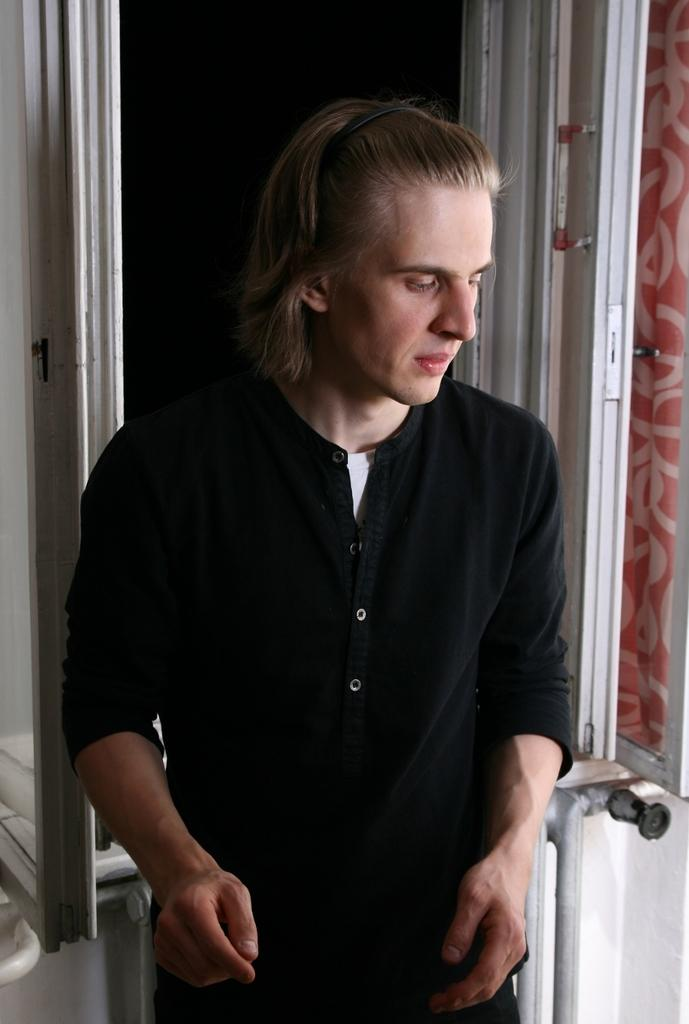Who or what is present in the image? There is a person in the image. What is the person standing or leaning against? There is a wall in the image. What material is visible in the image? There is cloth in the image. What else can be seen in the image besides the person and the wall? There are objects in the image. How would you describe the overall appearance of the image? The background of the image is dark. What type of theory is being discussed in the image? There is no indication in the image that a theory is being discussed. --- Facts: 1. There is a car in the image. 2. The car is red. 3. The car has four wheels. 4. There are people in the car. 5. The car is parked on the street. Absurd Topics: bird, ocean, mountain Conversation: What is the main subject of the image? The main subject of the image is a car. What color is the car? The car is red. How many wheels does the car have? The car has four wheels. Are there any passengers in the car? Yes, there are people in the car. Where is the car located in the image? The car is parked on the street. Reasoning: Let's think step by step in order to produce the conversation. We start by identifying the main subject in the image, which is the car. Then, we expand the conversation to include other details about the car, such as its color, number of wheels, and the presence of passengers. Finally, we describe the car's location in the image, which is parked on the street. Absurd Question/Answer: Can you see any mountains in the background of the image? There is no mountain visible in the image; it features a red car parked on the street. 